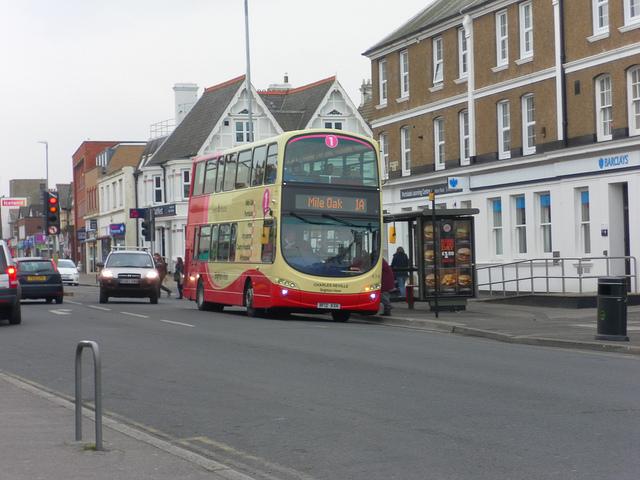Is this a small town?
Answer briefly. No. Are there bicycles?
Write a very short answer. No. Is this an enter one way street?
Quick response, please. No. Are the cars moving?
Short answer required. Yes. Is that a bus?
Keep it brief. Yes. What time of day is this scene taking place?
Concise answer only. Noon. How many seating levels are on the bus?
Be succinct. 2. Is a bus shelter visible?
Quick response, please. Yes. Is the street wet?
Keep it brief. No. Is the bus moving?
Write a very short answer. No. Where is the waste bin?
Answer briefly. On sidewalk. 